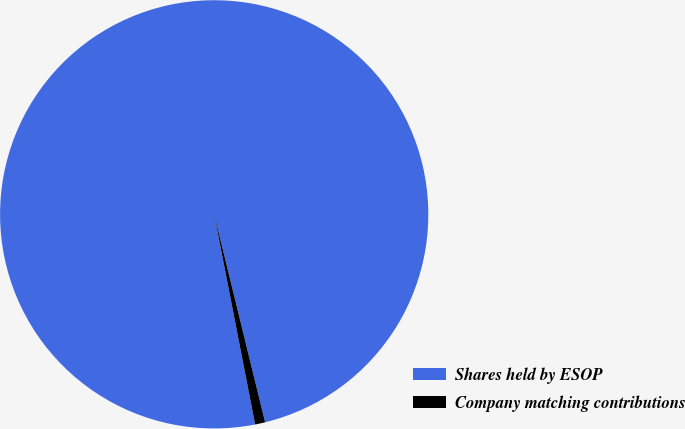Convert chart to OTSL. <chart><loc_0><loc_0><loc_500><loc_500><pie_chart><fcel>Shares held by ESOP<fcel>Company matching contributions<nl><fcel>99.24%<fcel>0.76%<nl></chart> 